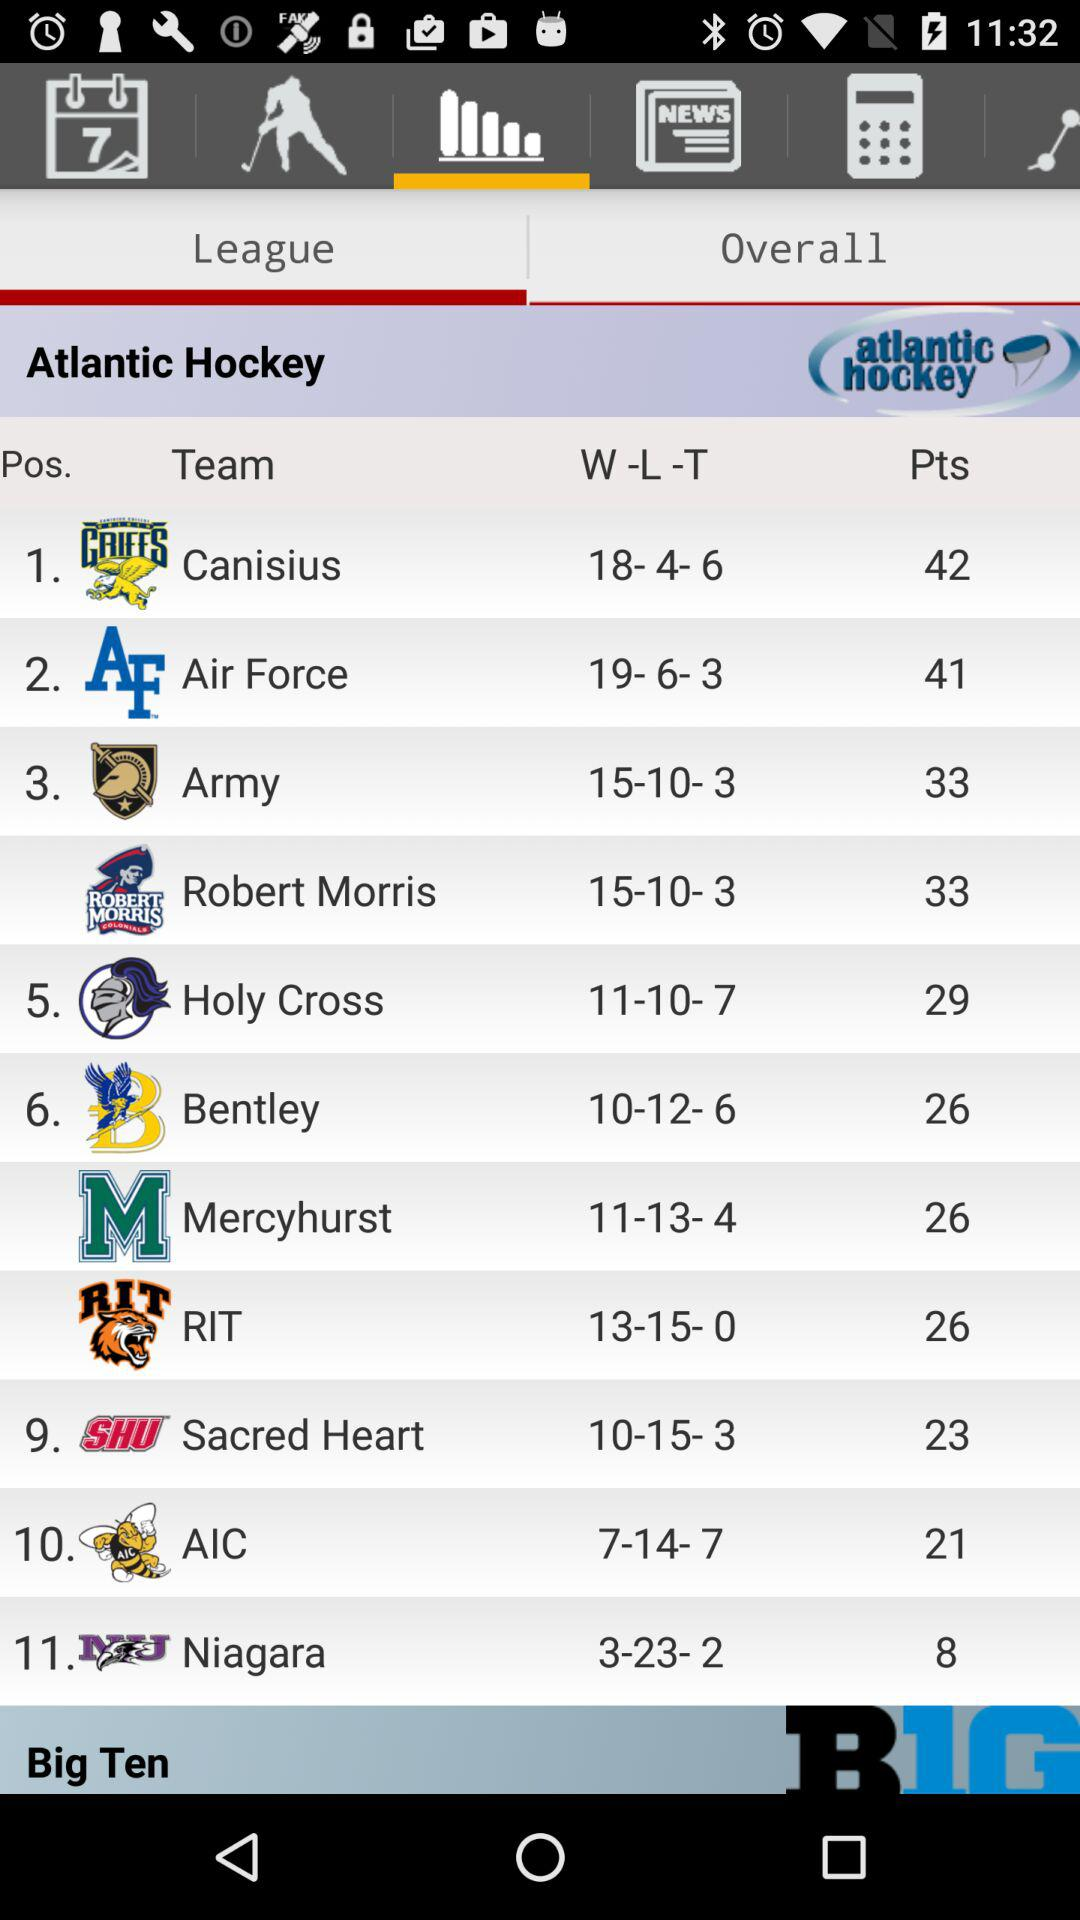How many more points does the team in first place have than the team in last place?
Answer the question using a single word or phrase. 34 